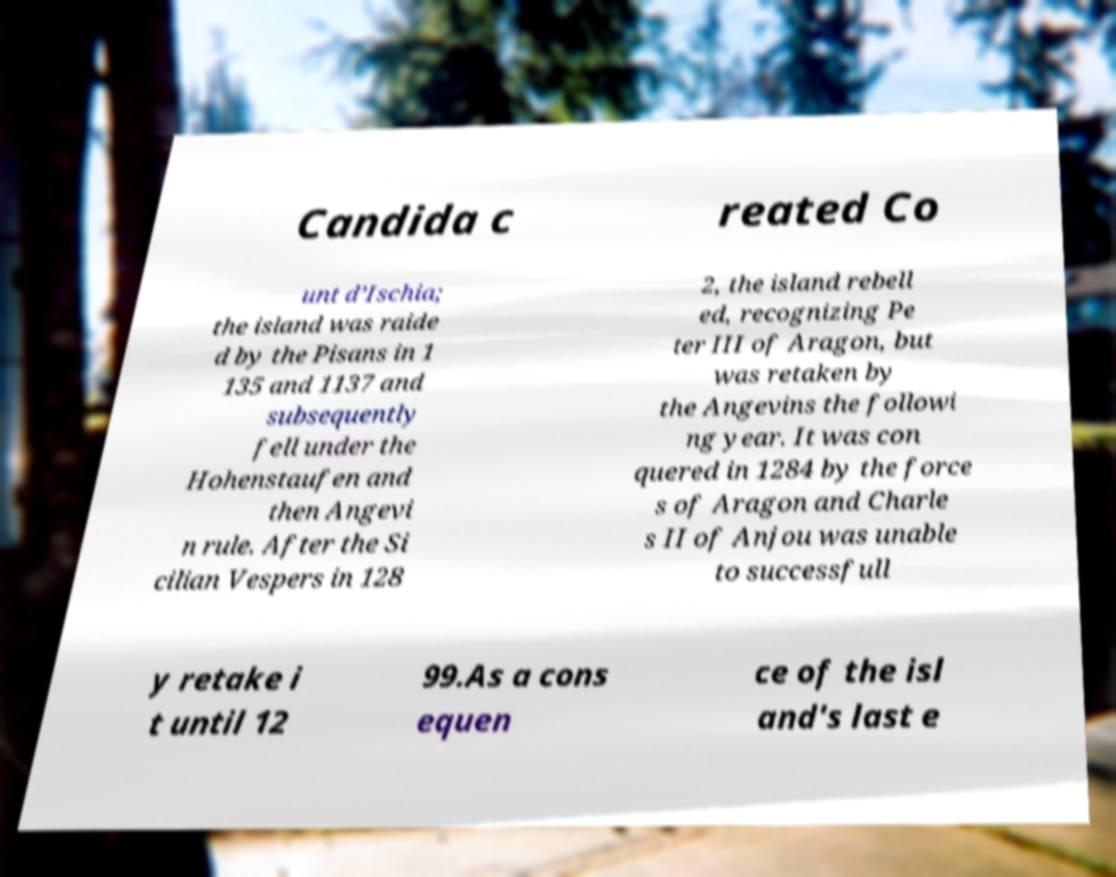Please identify and transcribe the text found in this image. Candida c reated Co unt d’Ischia; the island was raide d by the Pisans in 1 135 and 1137 and subsequently fell under the Hohenstaufen and then Angevi n rule. After the Si cilian Vespers in 128 2, the island rebell ed, recognizing Pe ter III of Aragon, but was retaken by the Angevins the followi ng year. It was con quered in 1284 by the force s of Aragon and Charle s II of Anjou was unable to successfull y retake i t until 12 99.As a cons equen ce of the isl and's last e 